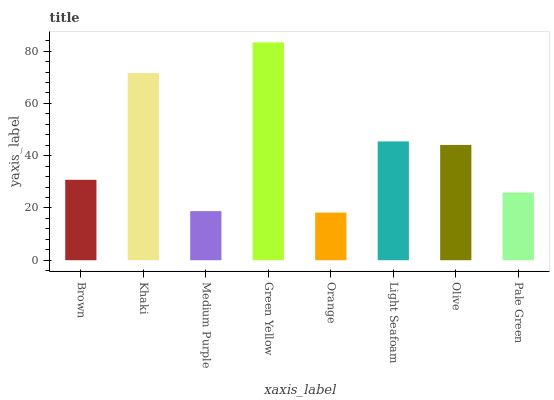Is Orange the minimum?
Answer yes or no. Yes. Is Green Yellow the maximum?
Answer yes or no. Yes. Is Khaki the minimum?
Answer yes or no. No. Is Khaki the maximum?
Answer yes or no. No. Is Khaki greater than Brown?
Answer yes or no. Yes. Is Brown less than Khaki?
Answer yes or no. Yes. Is Brown greater than Khaki?
Answer yes or no. No. Is Khaki less than Brown?
Answer yes or no. No. Is Olive the high median?
Answer yes or no. Yes. Is Brown the low median?
Answer yes or no. Yes. Is Green Yellow the high median?
Answer yes or no. No. Is Medium Purple the low median?
Answer yes or no. No. 